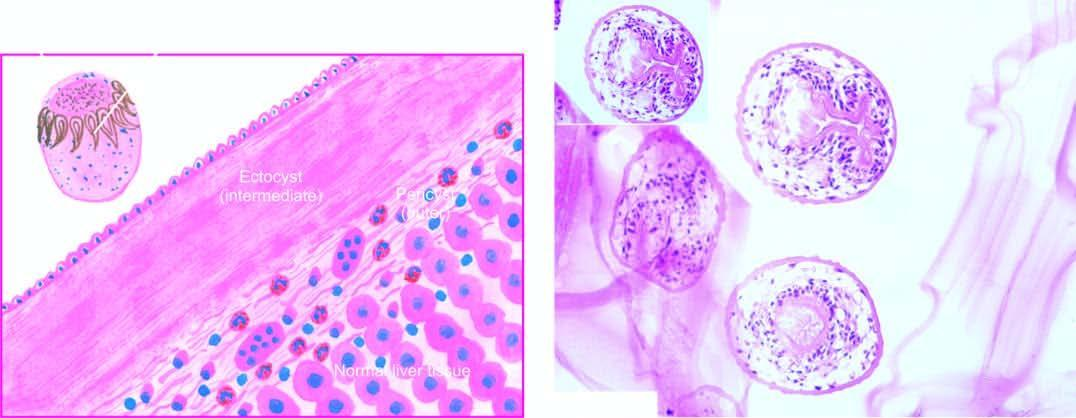how many layers does microscopy show?
Answer the question using a single word or phrase. Three 